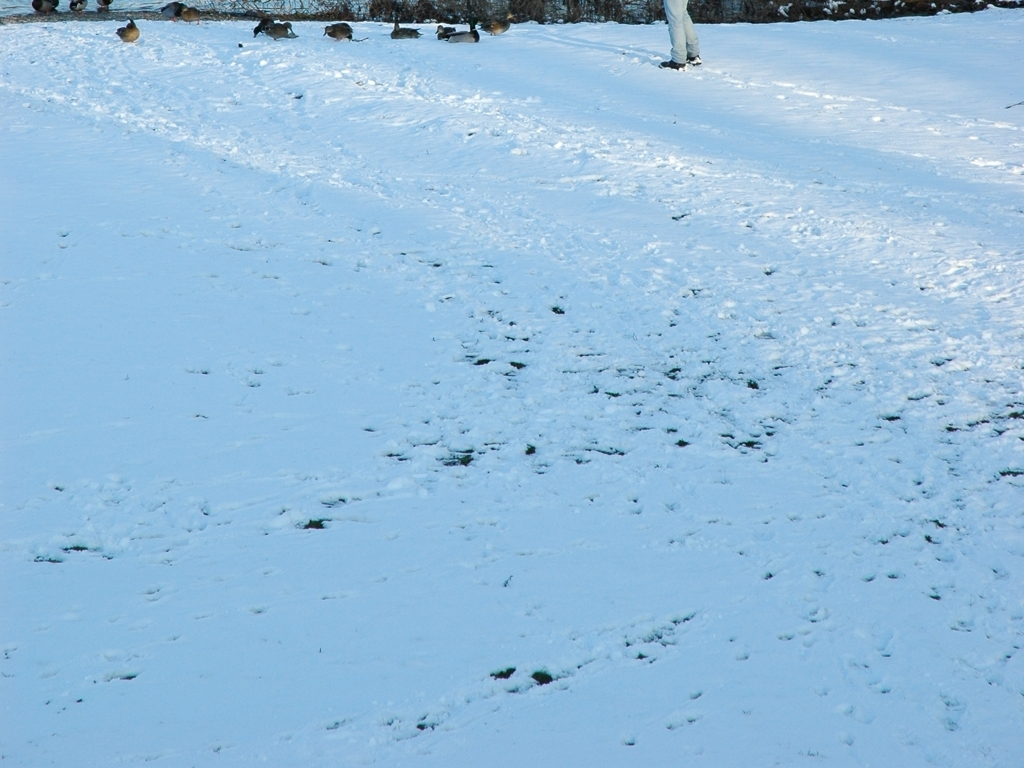Can this image accurately reproduce the color of snow? While the image does display the color of snow, it's important to note that several factors can affect color accuracy, such as lighting conditions and the device's display settings. The snow appears to have a slightly blue hue, which could be due to the shadow or the time of the day the picture was taken. For the most accurate color representation, it would be beneficial to view the snow in person or through a calibrated display. 